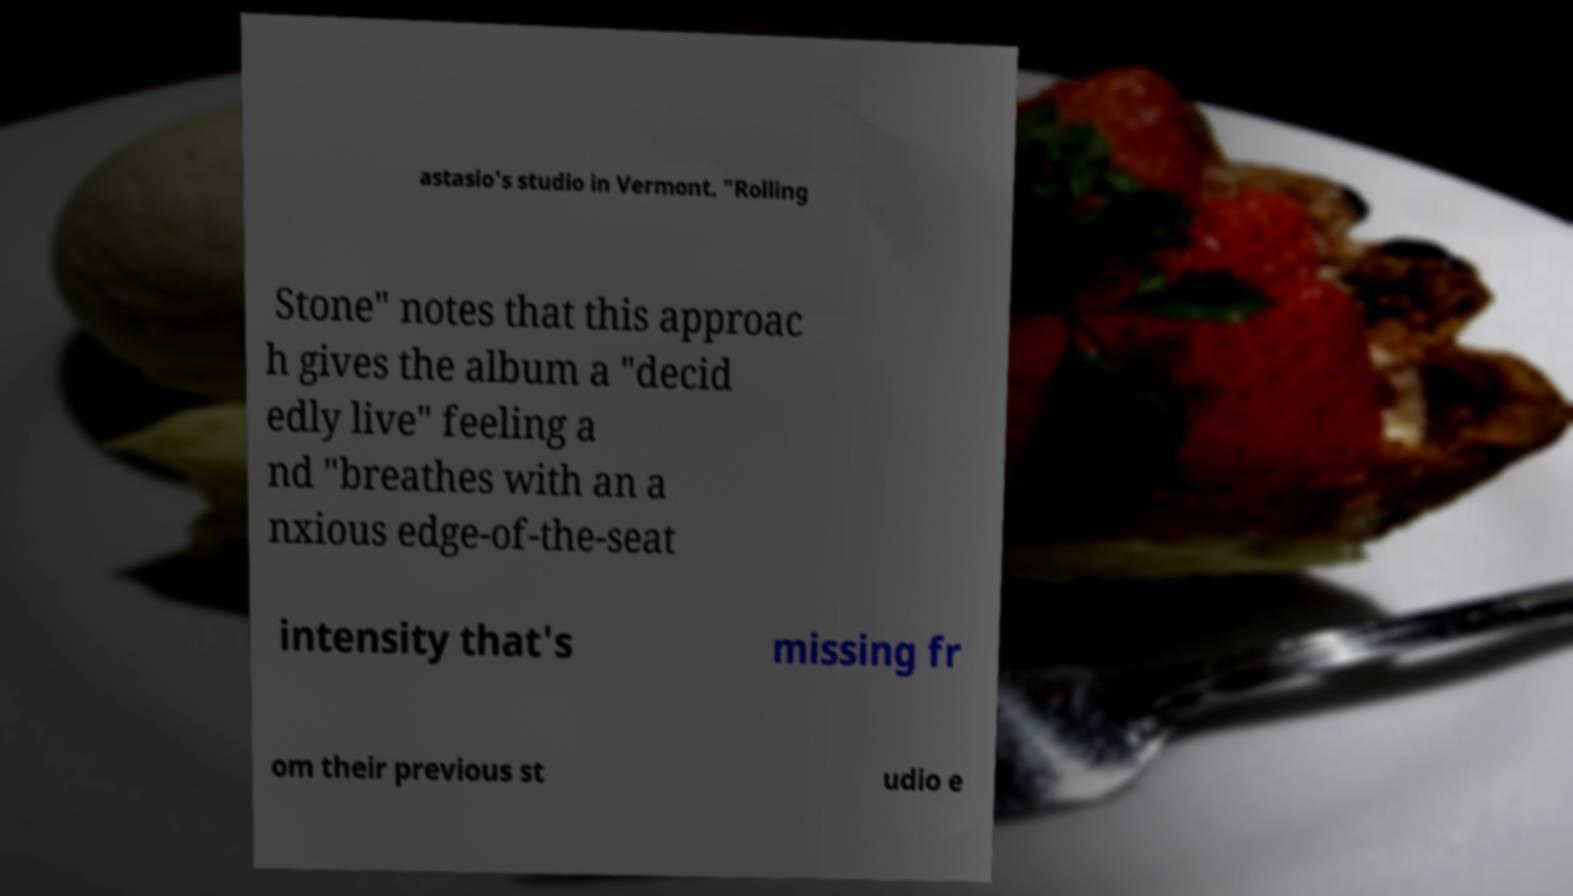What messages or text are displayed in this image? I need them in a readable, typed format. astasio's studio in Vermont. "Rolling Stone" notes that this approac h gives the album a "decid edly live" feeling a nd "breathes with an a nxious edge-of-the-seat intensity that's missing fr om their previous st udio e 